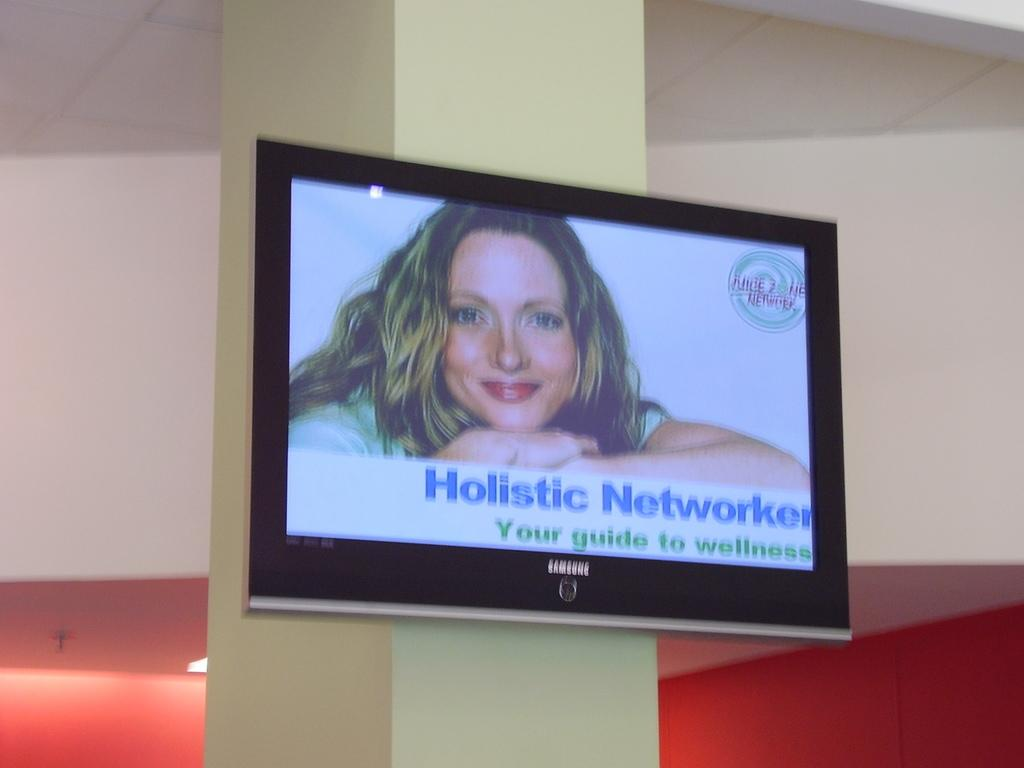<image>
Describe the image concisely. a Samsung TV displaying the message for Holistic Networker 